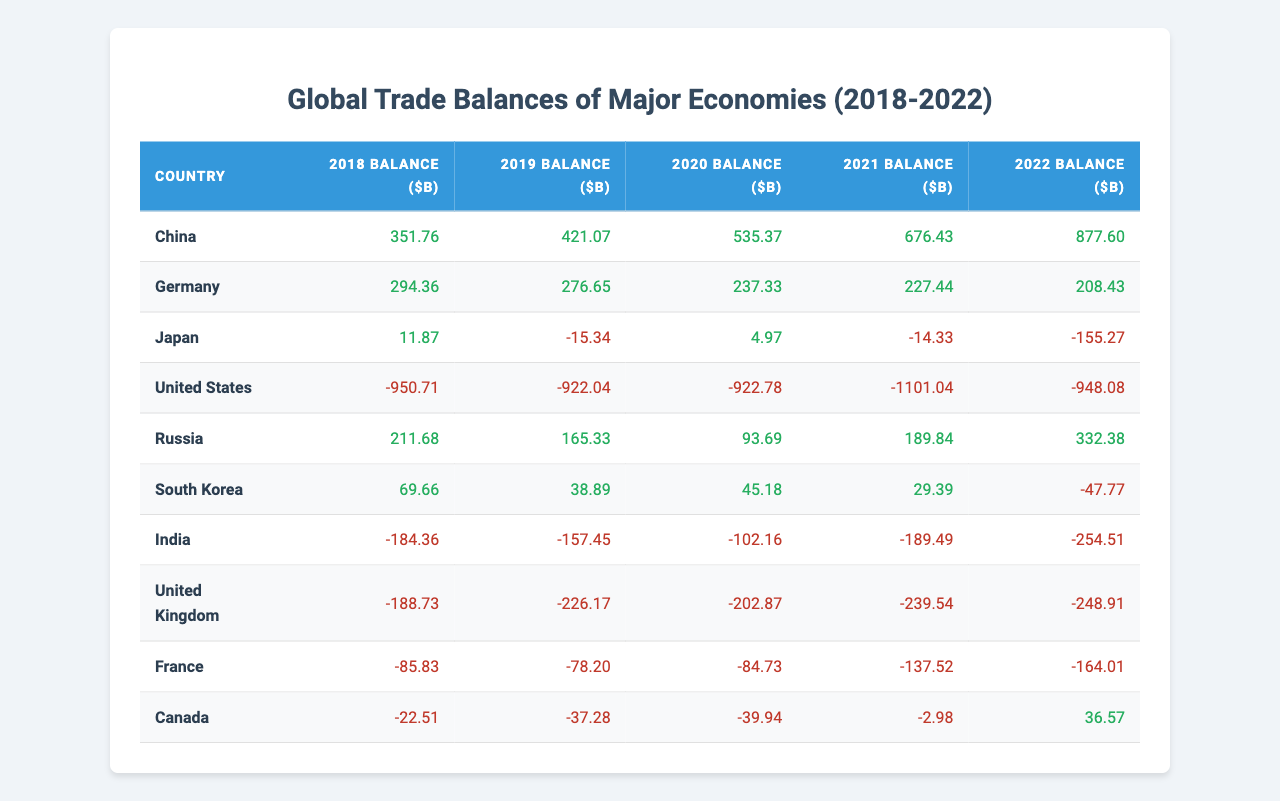What was China's trade balance in 2021? The table shows that China's trade balance in 2021 is 676.43 billion dollars.
Answer: 676.43 billion dollars Which country's trade balance was the lowest in 2020? The table indicates Japan had a trade balance of 4.97 billion dollars in 2020. As this is the only positive figure among the listed countries for that year, it is indeed the lowest trade balance.
Answer: Japan with 4.97 billion dollars What was the trend in Germany's trade balance from 2018 to 2022? Analyzing the values, Germany's trade balance decreased from 294.36 billion dollars in 2018 to 208.43 billion dollars in 2022, indicating a downward trend over the five years.
Answer: Decreasing trend What is the total trade balance for the United States from 2018 to 2022? Adding the trade balances from each year, the calculation is -950.71 + (-922.04) + (-922.78) + (-1101.04) + (-948.08) = -3844.65 billion dollars.
Answer: -3844.65 billion dollars Which country had the largest trade surplus in 2022, and what was it? According to the table, China had the largest trade surplus in 2022 at 877.60 billion dollars, compared to the other countries listed.
Answer: China with 877.60 billion dollars What is the average trade balance of Canada over the years 2018 to 2022? First, sum Canada's trade balances: -22.51 + (-37.28) + (-39.94) + (-2.98) + 36.57 = -66.14 billion dollars. There are 5 years, so the average is -66.14 / 5 = -13.23 billion dollars.
Answer: -13.23 billion dollars Did India's trade balance improve or worsen from 2021 to 2022? By analyzing the figures, India's trade balance was -189.49 billion dollars in 2021 and worsened to -254.51 billion dollars in 2022, thus indicating a negative change.
Answer: Worsened How much higher was China's trade balance in 2022 compared to Germany's in the same year? China's trade balance in 2022 was 877.60 billion dollars while Germany's was 208.43 billion dollars. The difference is 877.60 - 208.43 = 669.17 billion dollars.
Answer: 669.17 billion dollars Which country experienced a positive trade balance trend over the years? Upon reviewing the data, China shows consistent positive trade balances from 2018 to 2022, thus indicating a positive trend.
Answer: China What was the overall change in Japan’s trade balance from 2018 to 2022? Japan's trade balance decreased from 11.87 billion dollars in 2018 to -155.27 billion dollars in 2022. The overall change is -155.27 - 11.87 = -167.14 billion dollars, reflecting a significant decline.
Answer: -167.14 billion dollars Is the average trade balance of all countries listed over 2018 to 2022 positive or negative? Summing all balances gives a total of 351.76 + 294.36 + 11.87 - 950.71 + 211.68 + 69.66 - 184.36 - 188.73 - 85.83 - 22.51 = -95.06 billion dollars. Since the total is negative and dividing by 10 yields a negative average, it is indeed negative.
Answer: Negative 